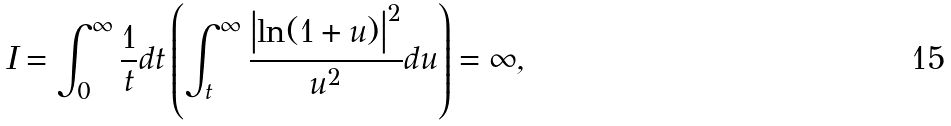Convert formula to latex. <formula><loc_0><loc_0><loc_500><loc_500>I = \int _ { 0 } ^ { \infty } \frac { 1 } { t } d t \left ( \int _ { t } ^ { \infty } \frac { \left | \ln ( 1 + u ) \right | ^ { 2 } } { u ^ { 2 } } d u \right ) = \infty ,</formula> 